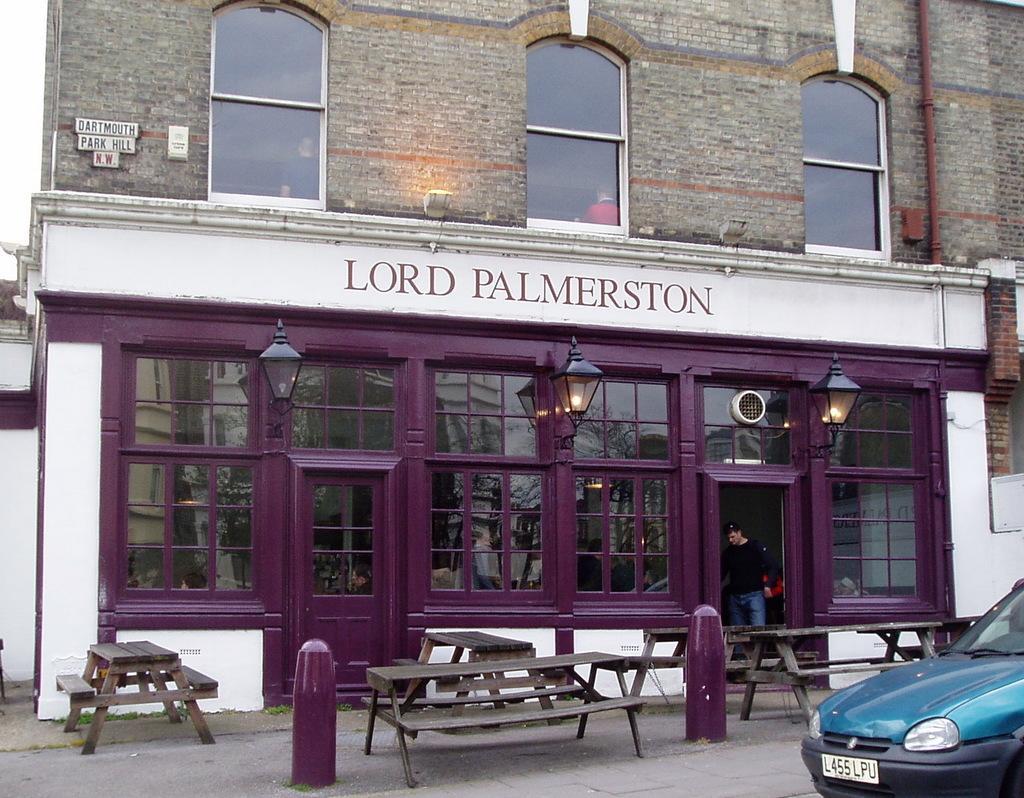Describe this image in one or two sentences. In this image I can see a person, a car, few benches, few lights and a building. 